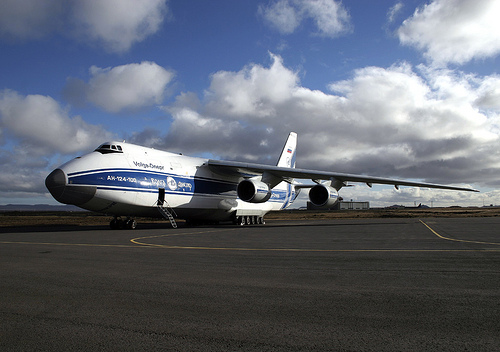<image>
Is the aircraft on the ground? Yes. Looking at the image, I can see the aircraft is positioned on top of the ground, with the ground providing support. 